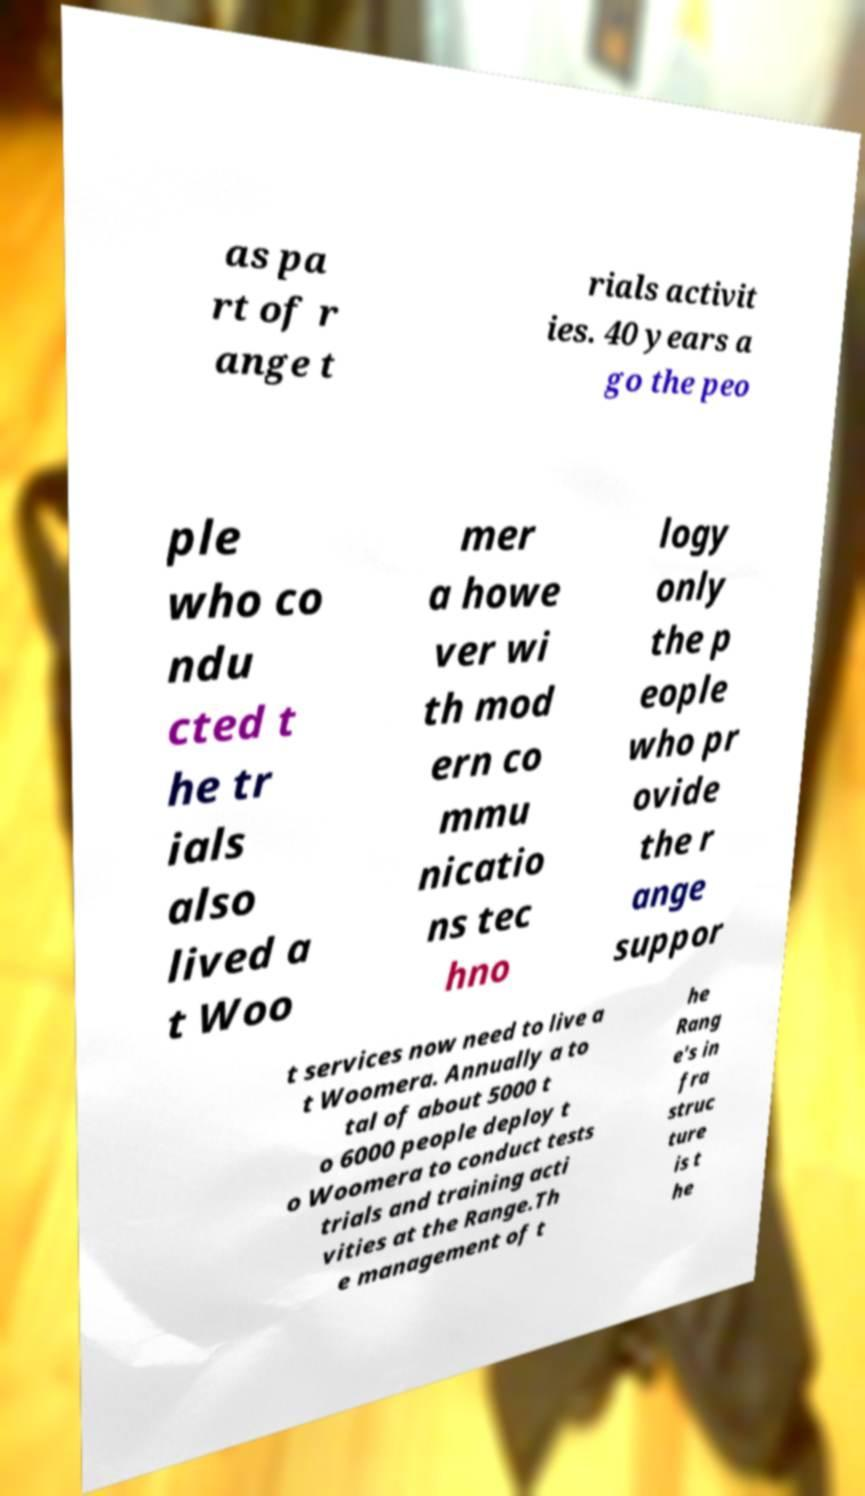Can you read and provide the text displayed in the image?This photo seems to have some interesting text. Can you extract and type it out for me? as pa rt of r ange t rials activit ies. 40 years a go the peo ple who co ndu cted t he tr ials also lived a t Woo mer a howe ver wi th mod ern co mmu nicatio ns tec hno logy only the p eople who pr ovide the r ange suppor t services now need to live a t Woomera. Annually a to tal of about 5000 t o 6000 people deploy t o Woomera to conduct tests trials and training acti vities at the Range.Th e management of t he Rang e's in fra struc ture is t he 